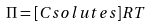Convert formula to latex. <formula><loc_0><loc_0><loc_500><loc_500>\Pi = [ C s o l u t e s ] R T</formula> 